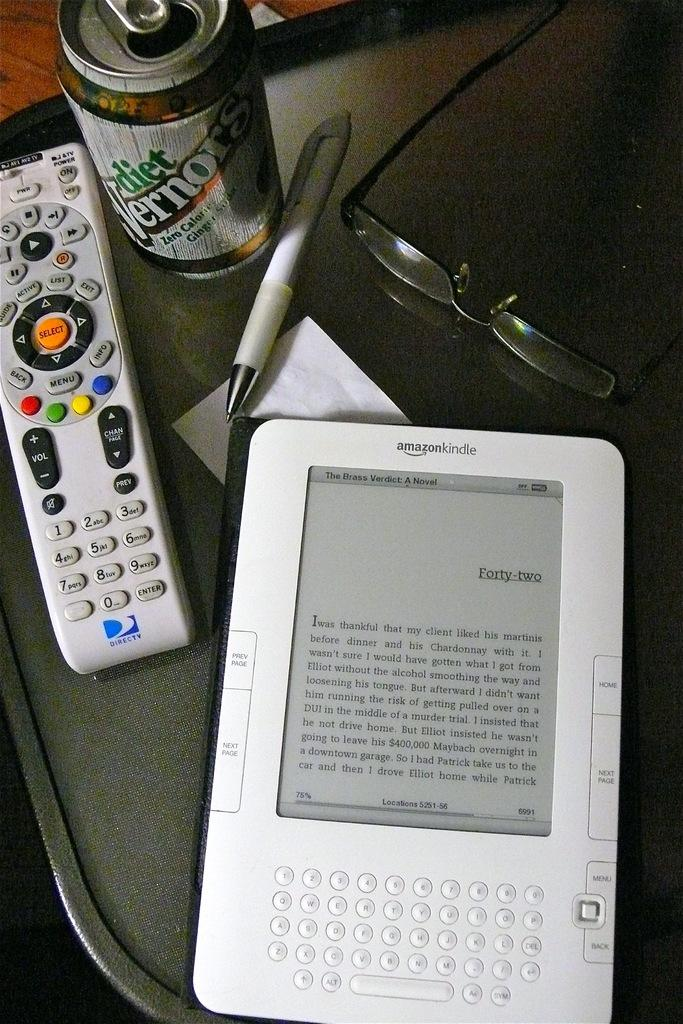<image>
Render a clear and concise summary of the photo. A white Amazon kindle sits on a table next to a remote and a pair of glasses 